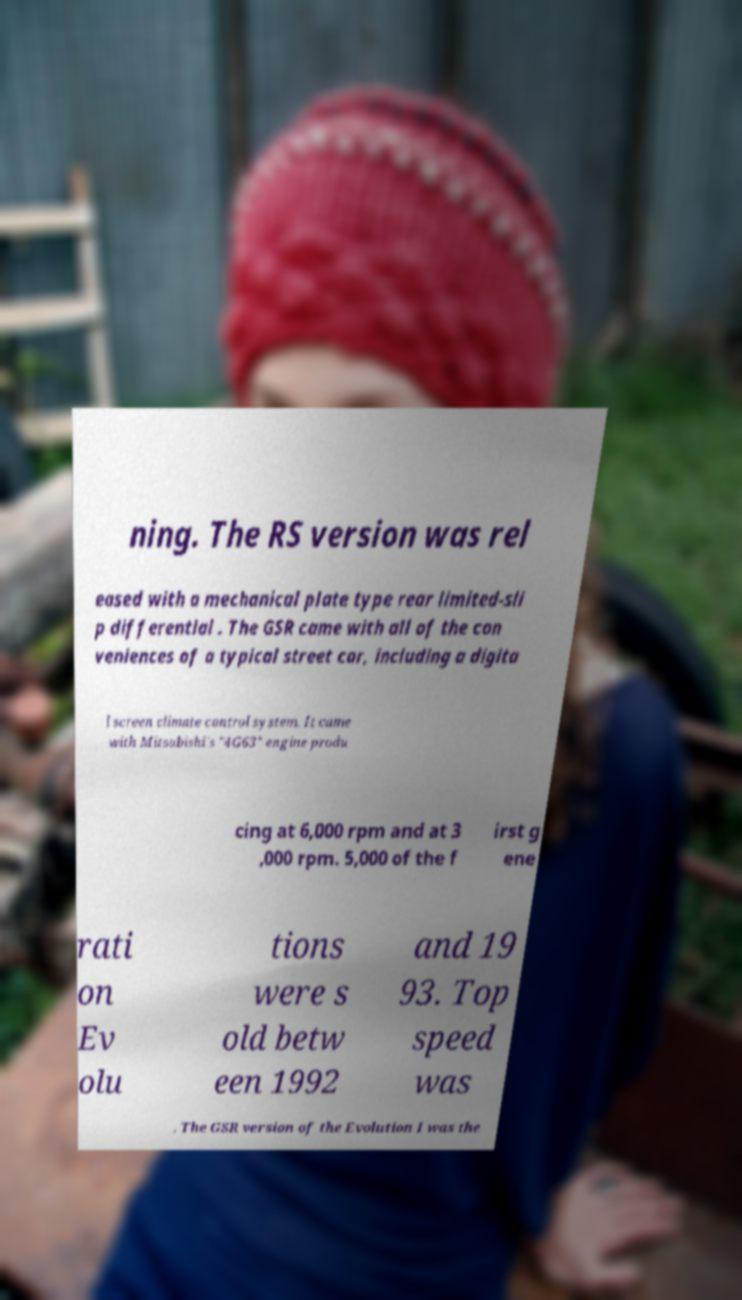What messages or text are displayed in this image? I need them in a readable, typed format. ning. The RS version was rel eased with a mechanical plate type rear limited-sli p differential . The GSR came with all of the con veniences of a typical street car, including a digita l screen climate control system. It came with Mitsubishi's "4G63" engine produ cing at 6,000 rpm and at 3 ,000 rpm. 5,000 of the f irst g ene rati on Ev olu tions were s old betw een 1992 and 19 93. Top speed was . The GSR version of the Evolution I was the 